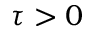Convert formula to latex. <formula><loc_0><loc_0><loc_500><loc_500>\tau > 0</formula> 